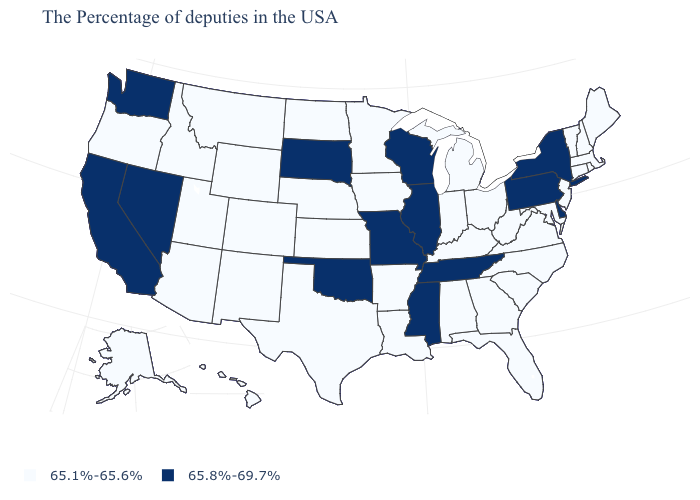What is the value of New Jersey?
Short answer required. 65.1%-65.6%. Name the states that have a value in the range 65.8%-69.7%?
Short answer required. New York, Delaware, Pennsylvania, Tennessee, Wisconsin, Illinois, Mississippi, Missouri, Oklahoma, South Dakota, Nevada, California, Washington. What is the value of Virginia?
Keep it brief. 65.1%-65.6%. What is the value of Arkansas?
Concise answer only. 65.1%-65.6%. Among the states that border Vermont , which have the highest value?
Give a very brief answer. New York. What is the lowest value in states that border Kentucky?
Short answer required. 65.1%-65.6%. Name the states that have a value in the range 65.1%-65.6%?
Be succinct. Maine, Massachusetts, Rhode Island, New Hampshire, Vermont, Connecticut, New Jersey, Maryland, Virginia, North Carolina, South Carolina, West Virginia, Ohio, Florida, Georgia, Michigan, Kentucky, Indiana, Alabama, Louisiana, Arkansas, Minnesota, Iowa, Kansas, Nebraska, Texas, North Dakota, Wyoming, Colorado, New Mexico, Utah, Montana, Arizona, Idaho, Oregon, Alaska, Hawaii. Does Nevada have a higher value than Ohio?
Answer briefly. Yes. Which states have the highest value in the USA?
Short answer required. New York, Delaware, Pennsylvania, Tennessee, Wisconsin, Illinois, Mississippi, Missouri, Oklahoma, South Dakota, Nevada, California, Washington. What is the lowest value in the Northeast?
Give a very brief answer. 65.1%-65.6%. Which states have the lowest value in the USA?
Keep it brief. Maine, Massachusetts, Rhode Island, New Hampshire, Vermont, Connecticut, New Jersey, Maryland, Virginia, North Carolina, South Carolina, West Virginia, Ohio, Florida, Georgia, Michigan, Kentucky, Indiana, Alabama, Louisiana, Arkansas, Minnesota, Iowa, Kansas, Nebraska, Texas, North Dakota, Wyoming, Colorado, New Mexico, Utah, Montana, Arizona, Idaho, Oregon, Alaska, Hawaii. Name the states that have a value in the range 65.1%-65.6%?
Short answer required. Maine, Massachusetts, Rhode Island, New Hampshire, Vermont, Connecticut, New Jersey, Maryland, Virginia, North Carolina, South Carolina, West Virginia, Ohio, Florida, Georgia, Michigan, Kentucky, Indiana, Alabama, Louisiana, Arkansas, Minnesota, Iowa, Kansas, Nebraska, Texas, North Dakota, Wyoming, Colorado, New Mexico, Utah, Montana, Arizona, Idaho, Oregon, Alaska, Hawaii. What is the value of California?
Be succinct. 65.8%-69.7%. What is the highest value in the MidWest ?
Give a very brief answer. 65.8%-69.7%. What is the value of Texas?
Concise answer only. 65.1%-65.6%. 